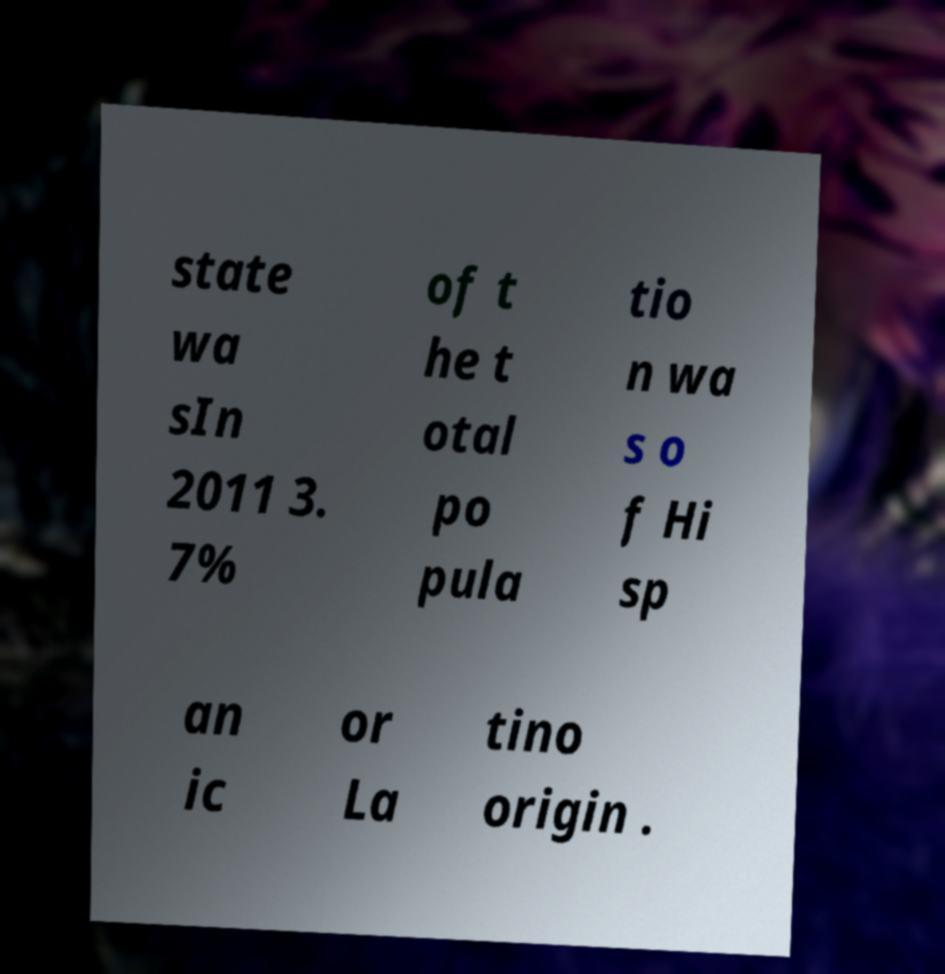There's text embedded in this image that I need extracted. Can you transcribe it verbatim? state wa sIn 2011 3. 7% of t he t otal po pula tio n wa s o f Hi sp an ic or La tino origin . 